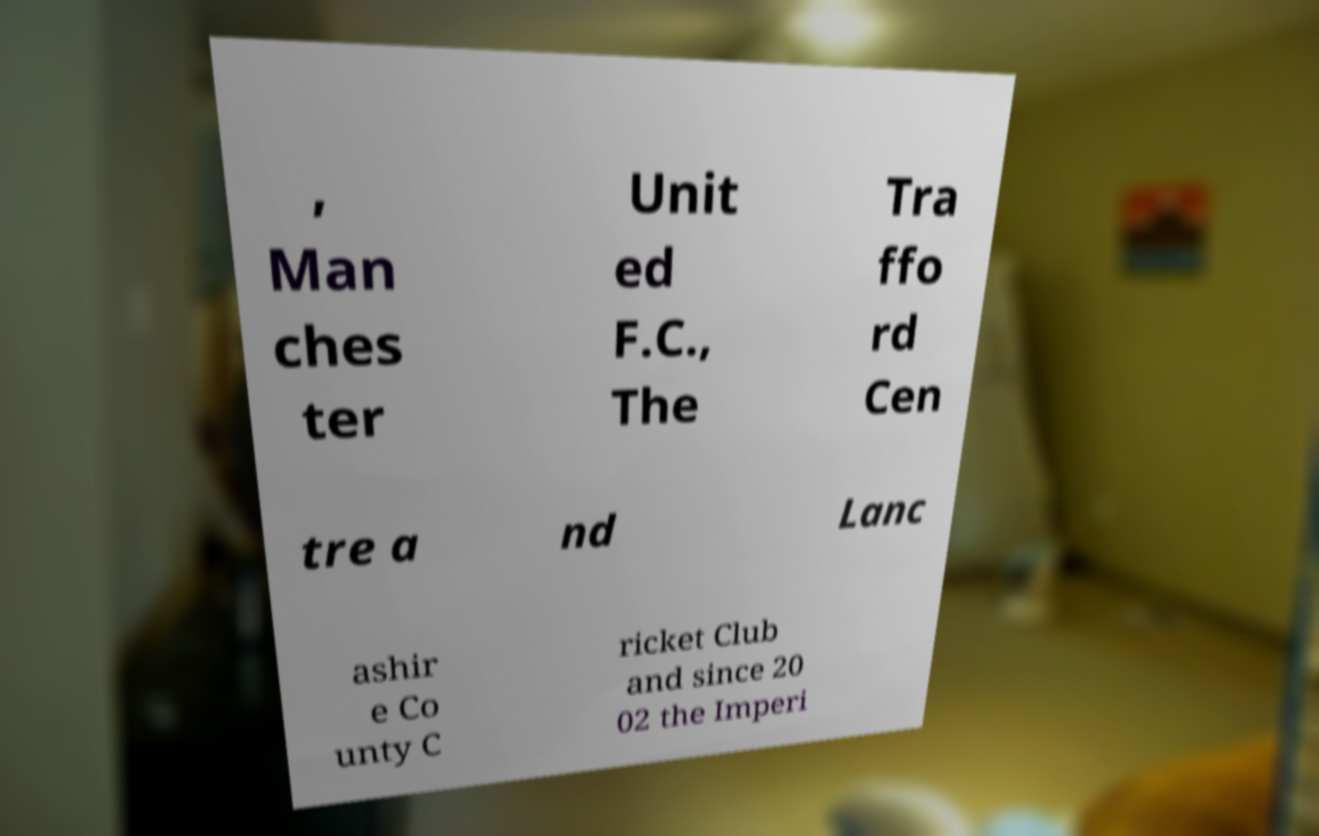Could you extract and type out the text from this image? , Man ches ter Unit ed F.C., The Tra ffo rd Cen tre a nd Lanc ashir e Co unty C ricket Club and since 20 02 the Imperi 